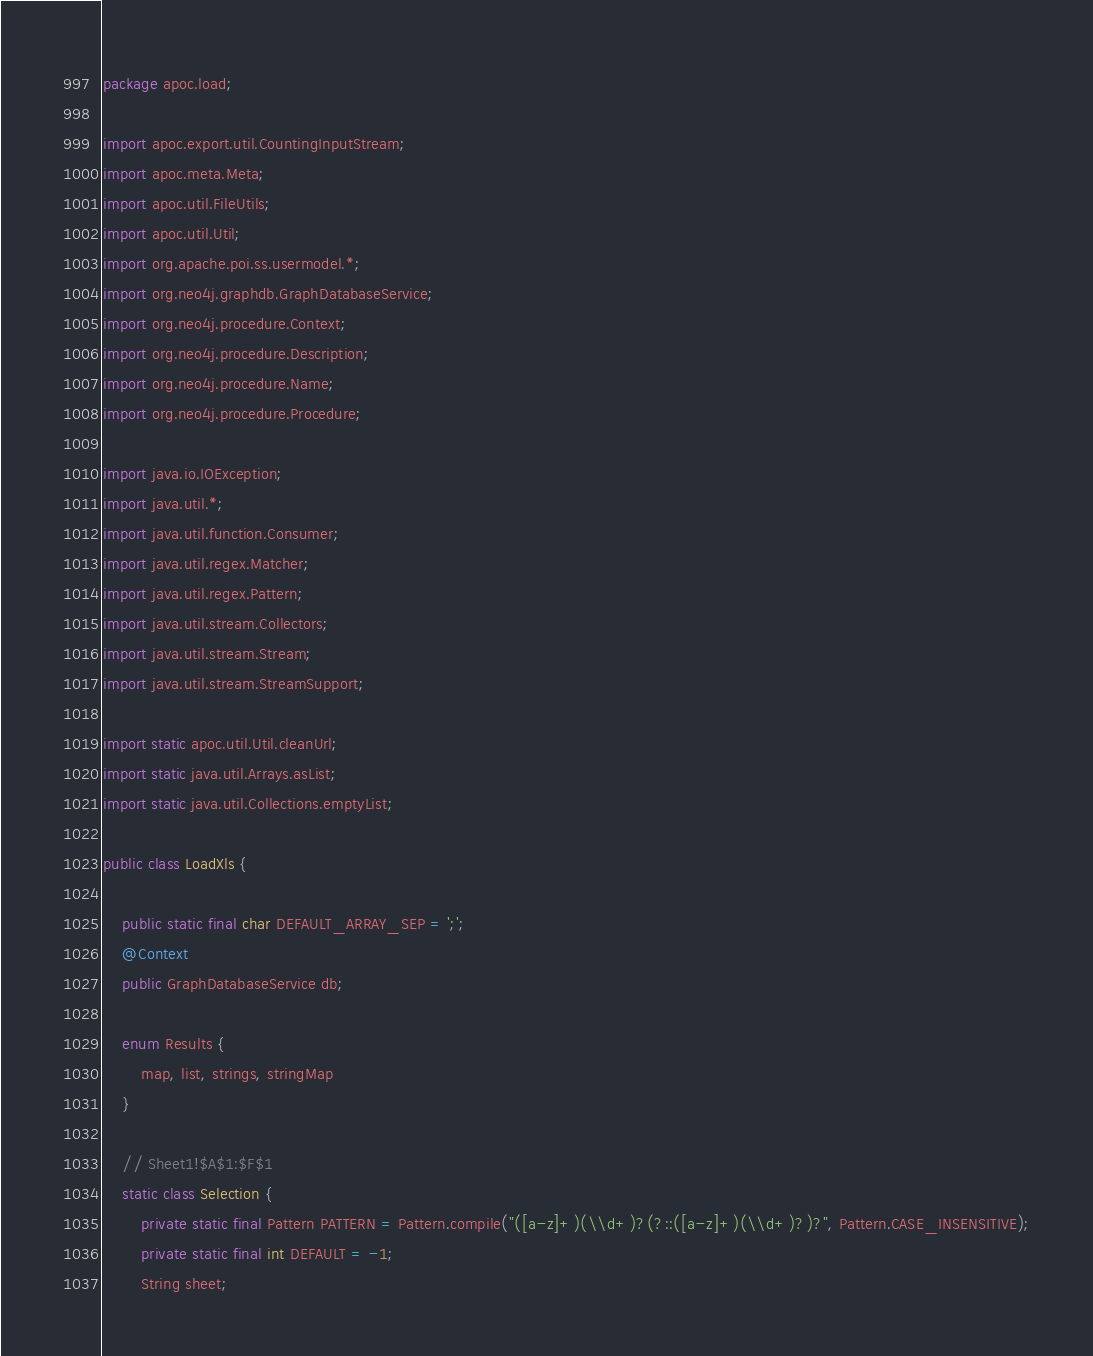<code> <loc_0><loc_0><loc_500><loc_500><_Java_>package apoc.load;

import apoc.export.util.CountingInputStream;
import apoc.meta.Meta;
import apoc.util.FileUtils;
import apoc.util.Util;
import org.apache.poi.ss.usermodel.*;
import org.neo4j.graphdb.GraphDatabaseService;
import org.neo4j.procedure.Context;
import org.neo4j.procedure.Description;
import org.neo4j.procedure.Name;
import org.neo4j.procedure.Procedure;

import java.io.IOException;
import java.util.*;
import java.util.function.Consumer;
import java.util.regex.Matcher;
import java.util.regex.Pattern;
import java.util.stream.Collectors;
import java.util.stream.Stream;
import java.util.stream.StreamSupport;

import static apoc.util.Util.cleanUrl;
import static java.util.Arrays.asList;
import static java.util.Collections.emptyList;

public class LoadXls {

    public static final char DEFAULT_ARRAY_SEP = ';';
    @Context
    public GraphDatabaseService db;

    enum Results {
        map, list, strings, stringMap
    }

    // Sheet1!$A$1:$F$1
    static class Selection {
        private static final Pattern PATTERN = Pattern.compile("([a-z]+)(\\d+)?(?::([a-z]+)(\\d+)?)?", Pattern.CASE_INSENSITIVE);
        private static final int DEFAULT = -1;
        String sheet;</code> 